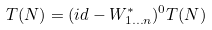<formula> <loc_0><loc_0><loc_500><loc_500>T ( N ) = ( i d - W ^ { \ast } _ { 1 \dots n } ) ^ { 0 } T ( N )</formula> 